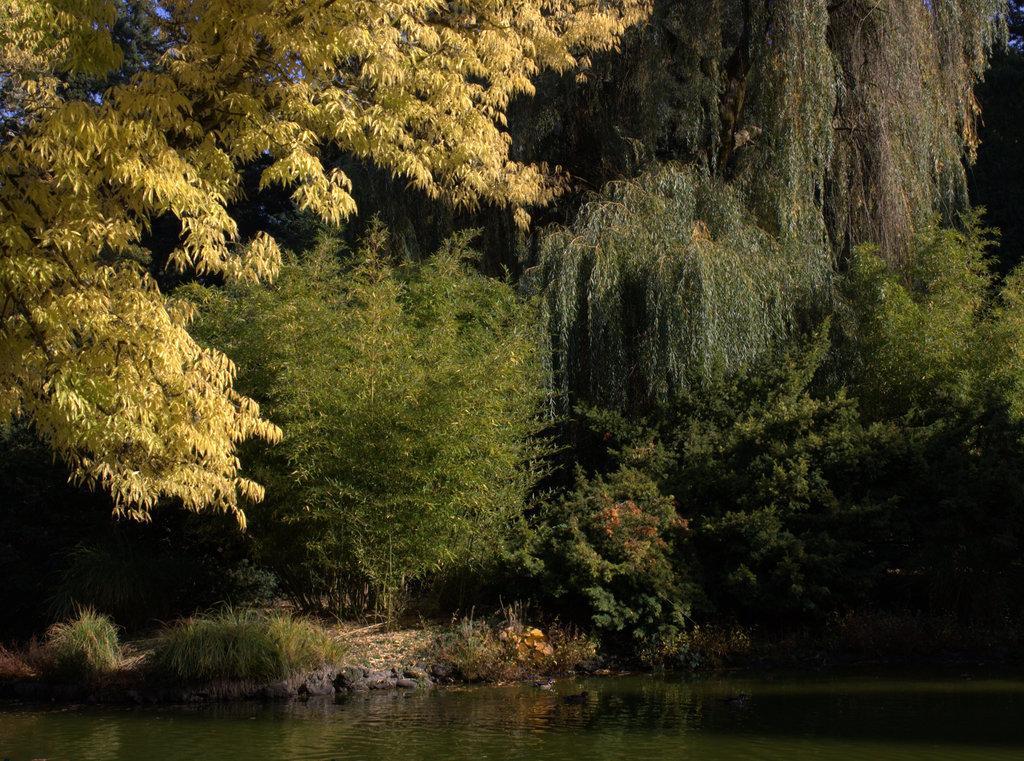Could you give a brief overview of what you see in this image? In this image we can see trees, water, grass, ground and sky. 